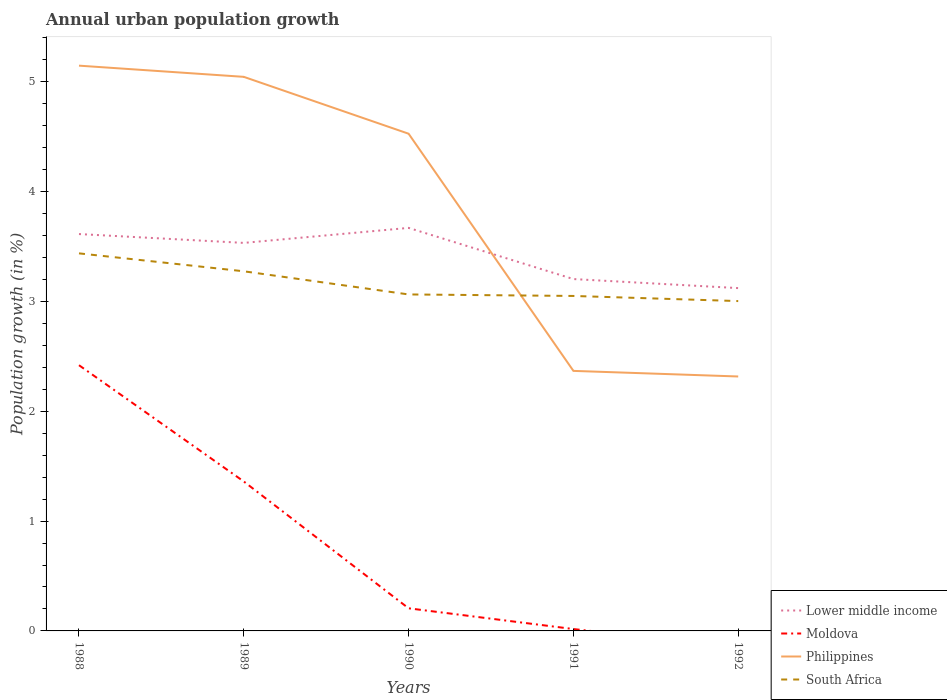Does the line corresponding to Lower middle income intersect with the line corresponding to Moldova?
Provide a short and direct response. No. Is the number of lines equal to the number of legend labels?
Provide a succinct answer. No. Across all years, what is the maximum percentage of urban population growth in Moldova?
Give a very brief answer. 0. What is the total percentage of urban population growth in Lower middle income in the graph?
Provide a succinct answer. 0.08. What is the difference between the highest and the second highest percentage of urban population growth in Philippines?
Give a very brief answer. 2.83. How many lines are there?
Keep it short and to the point. 4. Are the values on the major ticks of Y-axis written in scientific E-notation?
Keep it short and to the point. No. Does the graph contain any zero values?
Keep it short and to the point. Yes. Where does the legend appear in the graph?
Provide a succinct answer. Bottom right. How many legend labels are there?
Keep it short and to the point. 4. What is the title of the graph?
Give a very brief answer. Annual urban population growth. Does "Philippines" appear as one of the legend labels in the graph?
Your answer should be compact. Yes. What is the label or title of the Y-axis?
Offer a very short reply. Population growth (in %). What is the Population growth (in %) of Lower middle income in 1988?
Keep it short and to the point. 3.61. What is the Population growth (in %) in Moldova in 1988?
Give a very brief answer. 2.42. What is the Population growth (in %) of Philippines in 1988?
Keep it short and to the point. 5.15. What is the Population growth (in %) in South Africa in 1988?
Provide a succinct answer. 3.44. What is the Population growth (in %) of Lower middle income in 1989?
Provide a short and direct response. 3.53. What is the Population growth (in %) of Moldova in 1989?
Make the answer very short. 1.36. What is the Population growth (in %) in Philippines in 1989?
Your response must be concise. 5.04. What is the Population growth (in %) in South Africa in 1989?
Give a very brief answer. 3.27. What is the Population growth (in %) in Lower middle income in 1990?
Give a very brief answer. 3.67. What is the Population growth (in %) of Moldova in 1990?
Offer a very short reply. 0.21. What is the Population growth (in %) in Philippines in 1990?
Your answer should be very brief. 4.53. What is the Population growth (in %) in South Africa in 1990?
Give a very brief answer. 3.06. What is the Population growth (in %) in Lower middle income in 1991?
Give a very brief answer. 3.2. What is the Population growth (in %) of Moldova in 1991?
Your answer should be very brief. 0.02. What is the Population growth (in %) in Philippines in 1991?
Offer a terse response. 2.37. What is the Population growth (in %) of South Africa in 1991?
Give a very brief answer. 3.05. What is the Population growth (in %) in Lower middle income in 1992?
Your answer should be very brief. 3.12. What is the Population growth (in %) in Philippines in 1992?
Provide a succinct answer. 2.32. What is the Population growth (in %) in South Africa in 1992?
Ensure brevity in your answer.  3. Across all years, what is the maximum Population growth (in %) of Lower middle income?
Make the answer very short. 3.67. Across all years, what is the maximum Population growth (in %) of Moldova?
Provide a succinct answer. 2.42. Across all years, what is the maximum Population growth (in %) of Philippines?
Your answer should be compact. 5.15. Across all years, what is the maximum Population growth (in %) of South Africa?
Offer a very short reply. 3.44. Across all years, what is the minimum Population growth (in %) in Lower middle income?
Ensure brevity in your answer.  3.12. Across all years, what is the minimum Population growth (in %) in Moldova?
Your answer should be compact. 0. Across all years, what is the minimum Population growth (in %) in Philippines?
Make the answer very short. 2.32. Across all years, what is the minimum Population growth (in %) of South Africa?
Offer a terse response. 3. What is the total Population growth (in %) of Lower middle income in the graph?
Offer a terse response. 17.14. What is the total Population growth (in %) of Moldova in the graph?
Your answer should be compact. 4. What is the total Population growth (in %) in Philippines in the graph?
Your answer should be compact. 19.4. What is the total Population growth (in %) of South Africa in the graph?
Provide a succinct answer. 15.83. What is the difference between the Population growth (in %) in Lower middle income in 1988 and that in 1989?
Keep it short and to the point. 0.08. What is the difference between the Population growth (in %) in Moldova in 1988 and that in 1989?
Provide a short and direct response. 1.06. What is the difference between the Population growth (in %) in Philippines in 1988 and that in 1989?
Provide a succinct answer. 0.1. What is the difference between the Population growth (in %) in South Africa in 1988 and that in 1989?
Provide a succinct answer. 0.16. What is the difference between the Population growth (in %) in Lower middle income in 1988 and that in 1990?
Offer a very short reply. -0.06. What is the difference between the Population growth (in %) in Moldova in 1988 and that in 1990?
Provide a succinct answer. 2.21. What is the difference between the Population growth (in %) of Philippines in 1988 and that in 1990?
Keep it short and to the point. 0.62. What is the difference between the Population growth (in %) in South Africa in 1988 and that in 1990?
Ensure brevity in your answer.  0.37. What is the difference between the Population growth (in %) in Lower middle income in 1988 and that in 1991?
Your response must be concise. 0.41. What is the difference between the Population growth (in %) in Moldova in 1988 and that in 1991?
Provide a short and direct response. 2.4. What is the difference between the Population growth (in %) in Philippines in 1988 and that in 1991?
Provide a succinct answer. 2.78. What is the difference between the Population growth (in %) of South Africa in 1988 and that in 1991?
Make the answer very short. 0.39. What is the difference between the Population growth (in %) in Lower middle income in 1988 and that in 1992?
Give a very brief answer. 0.49. What is the difference between the Population growth (in %) of Philippines in 1988 and that in 1992?
Offer a very short reply. 2.83. What is the difference between the Population growth (in %) in South Africa in 1988 and that in 1992?
Your answer should be compact. 0.43. What is the difference between the Population growth (in %) of Lower middle income in 1989 and that in 1990?
Offer a very short reply. -0.14. What is the difference between the Population growth (in %) of Moldova in 1989 and that in 1990?
Your answer should be compact. 1.15. What is the difference between the Population growth (in %) of Philippines in 1989 and that in 1990?
Provide a succinct answer. 0.52. What is the difference between the Population growth (in %) of South Africa in 1989 and that in 1990?
Offer a terse response. 0.21. What is the difference between the Population growth (in %) in Lower middle income in 1989 and that in 1991?
Provide a succinct answer. 0.33. What is the difference between the Population growth (in %) of Moldova in 1989 and that in 1991?
Keep it short and to the point. 1.34. What is the difference between the Population growth (in %) in Philippines in 1989 and that in 1991?
Provide a succinct answer. 2.68. What is the difference between the Population growth (in %) of South Africa in 1989 and that in 1991?
Provide a succinct answer. 0.22. What is the difference between the Population growth (in %) of Lower middle income in 1989 and that in 1992?
Keep it short and to the point. 0.41. What is the difference between the Population growth (in %) of Philippines in 1989 and that in 1992?
Give a very brief answer. 2.73. What is the difference between the Population growth (in %) in South Africa in 1989 and that in 1992?
Make the answer very short. 0.27. What is the difference between the Population growth (in %) in Lower middle income in 1990 and that in 1991?
Ensure brevity in your answer.  0.47. What is the difference between the Population growth (in %) in Moldova in 1990 and that in 1991?
Keep it short and to the point. 0.19. What is the difference between the Population growth (in %) of Philippines in 1990 and that in 1991?
Your response must be concise. 2.16. What is the difference between the Population growth (in %) in South Africa in 1990 and that in 1991?
Provide a succinct answer. 0.01. What is the difference between the Population growth (in %) of Lower middle income in 1990 and that in 1992?
Your response must be concise. 0.55. What is the difference between the Population growth (in %) of Philippines in 1990 and that in 1992?
Keep it short and to the point. 2.21. What is the difference between the Population growth (in %) in South Africa in 1990 and that in 1992?
Provide a succinct answer. 0.06. What is the difference between the Population growth (in %) in Lower middle income in 1991 and that in 1992?
Give a very brief answer. 0.08. What is the difference between the Population growth (in %) in Philippines in 1991 and that in 1992?
Ensure brevity in your answer.  0.05. What is the difference between the Population growth (in %) in South Africa in 1991 and that in 1992?
Keep it short and to the point. 0.05. What is the difference between the Population growth (in %) in Lower middle income in 1988 and the Population growth (in %) in Moldova in 1989?
Provide a short and direct response. 2.25. What is the difference between the Population growth (in %) of Lower middle income in 1988 and the Population growth (in %) of Philippines in 1989?
Your answer should be very brief. -1.43. What is the difference between the Population growth (in %) of Lower middle income in 1988 and the Population growth (in %) of South Africa in 1989?
Provide a succinct answer. 0.34. What is the difference between the Population growth (in %) in Moldova in 1988 and the Population growth (in %) in Philippines in 1989?
Provide a succinct answer. -2.63. What is the difference between the Population growth (in %) of Moldova in 1988 and the Population growth (in %) of South Africa in 1989?
Your response must be concise. -0.86. What is the difference between the Population growth (in %) of Philippines in 1988 and the Population growth (in %) of South Africa in 1989?
Provide a short and direct response. 1.87. What is the difference between the Population growth (in %) of Lower middle income in 1988 and the Population growth (in %) of Moldova in 1990?
Provide a short and direct response. 3.41. What is the difference between the Population growth (in %) of Lower middle income in 1988 and the Population growth (in %) of Philippines in 1990?
Ensure brevity in your answer.  -0.91. What is the difference between the Population growth (in %) of Lower middle income in 1988 and the Population growth (in %) of South Africa in 1990?
Offer a terse response. 0.55. What is the difference between the Population growth (in %) of Moldova in 1988 and the Population growth (in %) of Philippines in 1990?
Your answer should be compact. -2.11. What is the difference between the Population growth (in %) of Moldova in 1988 and the Population growth (in %) of South Africa in 1990?
Offer a terse response. -0.64. What is the difference between the Population growth (in %) in Philippines in 1988 and the Population growth (in %) in South Africa in 1990?
Make the answer very short. 2.08. What is the difference between the Population growth (in %) of Lower middle income in 1988 and the Population growth (in %) of Moldova in 1991?
Offer a very short reply. 3.6. What is the difference between the Population growth (in %) in Lower middle income in 1988 and the Population growth (in %) in Philippines in 1991?
Keep it short and to the point. 1.25. What is the difference between the Population growth (in %) of Lower middle income in 1988 and the Population growth (in %) of South Africa in 1991?
Your answer should be compact. 0.56. What is the difference between the Population growth (in %) in Moldova in 1988 and the Population growth (in %) in Philippines in 1991?
Offer a terse response. 0.05. What is the difference between the Population growth (in %) of Moldova in 1988 and the Population growth (in %) of South Africa in 1991?
Give a very brief answer. -0.63. What is the difference between the Population growth (in %) of Philippines in 1988 and the Population growth (in %) of South Africa in 1991?
Offer a very short reply. 2.1. What is the difference between the Population growth (in %) in Lower middle income in 1988 and the Population growth (in %) in Philippines in 1992?
Offer a terse response. 1.3. What is the difference between the Population growth (in %) in Lower middle income in 1988 and the Population growth (in %) in South Africa in 1992?
Your answer should be compact. 0.61. What is the difference between the Population growth (in %) in Moldova in 1988 and the Population growth (in %) in Philippines in 1992?
Keep it short and to the point. 0.1. What is the difference between the Population growth (in %) in Moldova in 1988 and the Population growth (in %) in South Africa in 1992?
Offer a very short reply. -0.58. What is the difference between the Population growth (in %) of Philippines in 1988 and the Population growth (in %) of South Africa in 1992?
Keep it short and to the point. 2.14. What is the difference between the Population growth (in %) in Lower middle income in 1989 and the Population growth (in %) in Moldova in 1990?
Your answer should be very brief. 3.33. What is the difference between the Population growth (in %) in Lower middle income in 1989 and the Population growth (in %) in Philippines in 1990?
Give a very brief answer. -0.99. What is the difference between the Population growth (in %) of Lower middle income in 1989 and the Population growth (in %) of South Africa in 1990?
Provide a succinct answer. 0.47. What is the difference between the Population growth (in %) in Moldova in 1989 and the Population growth (in %) in Philippines in 1990?
Provide a short and direct response. -3.17. What is the difference between the Population growth (in %) of Moldova in 1989 and the Population growth (in %) of South Africa in 1990?
Your response must be concise. -1.7. What is the difference between the Population growth (in %) in Philippines in 1989 and the Population growth (in %) in South Africa in 1990?
Your response must be concise. 1.98. What is the difference between the Population growth (in %) in Lower middle income in 1989 and the Population growth (in %) in Moldova in 1991?
Offer a terse response. 3.52. What is the difference between the Population growth (in %) of Lower middle income in 1989 and the Population growth (in %) of Philippines in 1991?
Offer a very short reply. 1.17. What is the difference between the Population growth (in %) of Lower middle income in 1989 and the Population growth (in %) of South Africa in 1991?
Your answer should be compact. 0.48. What is the difference between the Population growth (in %) in Moldova in 1989 and the Population growth (in %) in Philippines in 1991?
Your response must be concise. -1.01. What is the difference between the Population growth (in %) of Moldova in 1989 and the Population growth (in %) of South Africa in 1991?
Offer a very short reply. -1.69. What is the difference between the Population growth (in %) in Philippines in 1989 and the Population growth (in %) in South Africa in 1991?
Provide a succinct answer. 1.99. What is the difference between the Population growth (in %) of Lower middle income in 1989 and the Population growth (in %) of Philippines in 1992?
Keep it short and to the point. 1.22. What is the difference between the Population growth (in %) in Lower middle income in 1989 and the Population growth (in %) in South Africa in 1992?
Your answer should be compact. 0.53. What is the difference between the Population growth (in %) in Moldova in 1989 and the Population growth (in %) in Philippines in 1992?
Ensure brevity in your answer.  -0.96. What is the difference between the Population growth (in %) in Moldova in 1989 and the Population growth (in %) in South Africa in 1992?
Ensure brevity in your answer.  -1.64. What is the difference between the Population growth (in %) in Philippines in 1989 and the Population growth (in %) in South Africa in 1992?
Provide a succinct answer. 2.04. What is the difference between the Population growth (in %) of Lower middle income in 1990 and the Population growth (in %) of Moldova in 1991?
Your response must be concise. 3.65. What is the difference between the Population growth (in %) of Lower middle income in 1990 and the Population growth (in %) of Philippines in 1991?
Offer a very short reply. 1.3. What is the difference between the Population growth (in %) in Lower middle income in 1990 and the Population growth (in %) in South Africa in 1991?
Your answer should be very brief. 0.62. What is the difference between the Population growth (in %) of Moldova in 1990 and the Population growth (in %) of Philippines in 1991?
Offer a very short reply. -2.16. What is the difference between the Population growth (in %) in Moldova in 1990 and the Population growth (in %) in South Africa in 1991?
Provide a succinct answer. -2.84. What is the difference between the Population growth (in %) of Philippines in 1990 and the Population growth (in %) of South Africa in 1991?
Your response must be concise. 1.48. What is the difference between the Population growth (in %) of Lower middle income in 1990 and the Population growth (in %) of Philippines in 1992?
Offer a very short reply. 1.35. What is the difference between the Population growth (in %) in Lower middle income in 1990 and the Population growth (in %) in South Africa in 1992?
Provide a short and direct response. 0.67. What is the difference between the Population growth (in %) of Moldova in 1990 and the Population growth (in %) of Philippines in 1992?
Your answer should be compact. -2.11. What is the difference between the Population growth (in %) in Moldova in 1990 and the Population growth (in %) in South Africa in 1992?
Give a very brief answer. -2.8. What is the difference between the Population growth (in %) in Philippines in 1990 and the Population growth (in %) in South Africa in 1992?
Offer a very short reply. 1.52. What is the difference between the Population growth (in %) of Lower middle income in 1991 and the Population growth (in %) of Philippines in 1992?
Your response must be concise. 0.89. What is the difference between the Population growth (in %) in Lower middle income in 1991 and the Population growth (in %) in South Africa in 1992?
Provide a short and direct response. 0.2. What is the difference between the Population growth (in %) in Moldova in 1991 and the Population growth (in %) in Philippines in 1992?
Keep it short and to the point. -2.3. What is the difference between the Population growth (in %) of Moldova in 1991 and the Population growth (in %) of South Africa in 1992?
Keep it short and to the point. -2.99. What is the difference between the Population growth (in %) in Philippines in 1991 and the Population growth (in %) in South Africa in 1992?
Your answer should be compact. -0.64. What is the average Population growth (in %) of Lower middle income per year?
Make the answer very short. 3.43. What is the average Population growth (in %) of Moldova per year?
Offer a very short reply. 0.8. What is the average Population growth (in %) in Philippines per year?
Your answer should be very brief. 3.88. What is the average Population growth (in %) in South Africa per year?
Provide a short and direct response. 3.17. In the year 1988, what is the difference between the Population growth (in %) of Lower middle income and Population growth (in %) of Moldova?
Offer a terse response. 1.19. In the year 1988, what is the difference between the Population growth (in %) in Lower middle income and Population growth (in %) in Philippines?
Your answer should be compact. -1.53. In the year 1988, what is the difference between the Population growth (in %) in Lower middle income and Population growth (in %) in South Africa?
Your answer should be very brief. 0.18. In the year 1988, what is the difference between the Population growth (in %) of Moldova and Population growth (in %) of Philippines?
Your answer should be very brief. -2.73. In the year 1988, what is the difference between the Population growth (in %) of Moldova and Population growth (in %) of South Africa?
Your response must be concise. -1.02. In the year 1988, what is the difference between the Population growth (in %) of Philippines and Population growth (in %) of South Africa?
Your answer should be compact. 1.71. In the year 1989, what is the difference between the Population growth (in %) in Lower middle income and Population growth (in %) in Moldova?
Offer a terse response. 2.17. In the year 1989, what is the difference between the Population growth (in %) of Lower middle income and Population growth (in %) of Philippines?
Give a very brief answer. -1.51. In the year 1989, what is the difference between the Population growth (in %) of Lower middle income and Population growth (in %) of South Africa?
Ensure brevity in your answer.  0.26. In the year 1989, what is the difference between the Population growth (in %) of Moldova and Population growth (in %) of Philippines?
Your answer should be very brief. -3.68. In the year 1989, what is the difference between the Population growth (in %) in Moldova and Population growth (in %) in South Africa?
Keep it short and to the point. -1.91. In the year 1989, what is the difference between the Population growth (in %) of Philippines and Population growth (in %) of South Africa?
Ensure brevity in your answer.  1.77. In the year 1990, what is the difference between the Population growth (in %) of Lower middle income and Population growth (in %) of Moldova?
Offer a very short reply. 3.46. In the year 1990, what is the difference between the Population growth (in %) in Lower middle income and Population growth (in %) in Philippines?
Offer a terse response. -0.86. In the year 1990, what is the difference between the Population growth (in %) in Lower middle income and Population growth (in %) in South Africa?
Your answer should be very brief. 0.61. In the year 1990, what is the difference between the Population growth (in %) in Moldova and Population growth (in %) in Philippines?
Your answer should be very brief. -4.32. In the year 1990, what is the difference between the Population growth (in %) of Moldova and Population growth (in %) of South Africa?
Provide a succinct answer. -2.86. In the year 1990, what is the difference between the Population growth (in %) of Philippines and Population growth (in %) of South Africa?
Offer a terse response. 1.46. In the year 1991, what is the difference between the Population growth (in %) in Lower middle income and Population growth (in %) in Moldova?
Make the answer very short. 3.19. In the year 1991, what is the difference between the Population growth (in %) in Lower middle income and Population growth (in %) in Philippines?
Provide a short and direct response. 0.84. In the year 1991, what is the difference between the Population growth (in %) of Lower middle income and Population growth (in %) of South Africa?
Make the answer very short. 0.15. In the year 1991, what is the difference between the Population growth (in %) of Moldova and Population growth (in %) of Philippines?
Make the answer very short. -2.35. In the year 1991, what is the difference between the Population growth (in %) of Moldova and Population growth (in %) of South Africa?
Ensure brevity in your answer.  -3.03. In the year 1991, what is the difference between the Population growth (in %) in Philippines and Population growth (in %) in South Africa?
Offer a terse response. -0.68. In the year 1992, what is the difference between the Population growth (in %) in Lower middle income and Population growth (in %) in Philippines?
Offer a very short reply. 0.8. In the year 1992, what is the difference between the Population growth (in %) of Lower middle income and Population growth (in %) of South Africa?
Give a very brief answer. 0.12. In the year 1992, what is the difference between the Population growth (in %) in Philippines and Population growth (in %) in South Africa?
Your answer should be compact. -0.69. What is the ratio of the Population growth (in %) in Lower middle income in 1988 to that in 1989?
Provide a short and direct response. 1.02. What is the ratio of the Population growth (in %) of Moldova in 1988 to that in 1989?
Your response must be concise. 1.78. What is the ratio of the Population growth (in %) in Philippines in 1988 to that in 1989?
Make the answer very short. 1.02. What is the ratio of the Population growth (in %) in South Africa in 1988 to that in 1989?
Ensure brevity in your answer.  1.05. What is the ratio of the Population growth (in %) of Lower middle income in 1988 to that in 1990?
Provide a succinct answer. 0.98. What is the ratio of the Population growth (in %) of Moldova in 1988 to that in 1990?
Provide a short and direct response. 11.75. What is the ratio of the Population growth (in %) in Philippines in 1988 to that in 1990?
Offer a terse response. 1.14. What is the ratio of the Population growth (in %) of South Africa in 1988 to that in 1990?
Offer a very short reply. 1.12. What is the ratio of the Population growth (in %) of Lower middle income in 1988 to that in 1991?
Your answer should be very brief. 1.13. What is the ratio of the Population growth (in %) in Moldova in 1988 to that in 1991?
Your answer should be very brief. 141.28. What is the ratio of the Population growth (in %) of Philippines in 1988 to that in 1991?
Your answer should be compact. 2.17. What is the ratio of the Population growth (in %) in South Africa in 1988 to that in 1991?
Provide a short and direct response. 1.13. What is the ratio of the Population growth (in %) in Lower middle income in 1988 to that in 1992?
Your answer should be very brief. 1.16. What is the ratio of the Population growth (in %) in Philippines in 1988 to that in 1992?
Give a very brief answer. 2.22. What is the ratio of the Population growth (in %) of South Africa in 1988 to that in 1992?
Ensure brevity in your answer.  1.14. What is the ratio of the Population growth (in %) of Lower middle income in 1989 to that in 1990?
Make the answer very short. 0.96. What is the ratio of the Population growth (in %) in Moldova in 1989 to that in 1990?
Your answer should be compact. 6.61. What is the ratio of the Population growth (in %) of Philippines in 1989 to that in 1990?
Your response must be concise. 1.11. What is the ratio of the Population growth (in %) of South Africa in 1989 to that in 1990?
Your answer should be very brief. 1.07. What is the ratio of the Population growth (in %) in Lower middle income in 1989 to that in 1991?
Offer a terse response. 1.1. What is the ratio of the Population growth (in %) in Moldova in 1989 to that in 1991?
Your answer should be very brief. 79.45. What is the ratio of the Population growth (in %) in Philippines in 1989 to that in 1991?
Provide a short and direct response. 2.13. What is the ratio of the Population growth (in %) in South Africa in 1989 to that in 1991?
Ensure brevity in your answer.  1.07. What is the ratio of the Population growth (in %) in Lower middle income in 1989 to that in 1992?
Provide a short and direct response. 1.13. What is the ratio of the Population growth (in %) of Philippines in 1989 to that in 1992?
Keep it short and to the point. 2.18. What is the ratio of the Population growth (in %) in South Africa in 1989 to that in 1992?
Give a very brief answer. 1.09. What is the ratio of the Population growth (in %) of Lower middle income in 1990 to that in 1991?
Your answer should be compact. 1.15. What is the ratio of the Population growth (in %) of Moldova in 1990 to that in 1991?
Your response must be concise. 12.02. What is the ratio of the Population growth (in %) in Philippines in 1990 to that in 1991?
Keep it short and to the point. 1.91. What is the ratio of the Population growth (in %) of Lower middle income in 1990 to that in 1992?
Ensure brevity in your answer.  1.18. What is the ratio of the Population growth (in %) in Philippines in 1990 to that in 1992?
Ensure brevity in your answer.  1.95. What is the ratio of the Population growth (in %) in South Africa in 1990 to that in 1992?
Provide a succinct answer. 1.02. What is the ratio of the Population growth (in %) in Lower middle income in 1991 to that in 1992?
Give a very brief answer. 1.03. What is the ratio of the Population growth (in %) of South Africa in 1991 to that in 1992?
Your response must be concise. 1.02. What is the difference between the highest and the second highest Population growth (in %) in Lower middle income?
Your answer should be compact. 0.06. What is the difference between the highest and the second highest Population growth (in %) in Moldova?
Offer a very short reply. 1.06. What is the difference between the highest and the second highest Population growth (in %) of Philippines?
Your response must be concise. 0.1. What is the difference between the highest and the second highest Population growth (in %) of South Africa?
Your response must be concise. 0.16. What is the difference between the highest and the lowest Population growth (in %) in Lower middle income?
Offer a terse response. 0.55. What is the difference between the highest and the lowest Population growth (in %) in Moldova?
Your response must be concise. 2.42. What is the difference between the highest and the lowest Population growth (in %) in Philippines?
Give a very brief answer. 2.83. What is the difference between the highest and the lowest Population growth (in %) in South Africa?
Offer a very short reply. 0.43. 